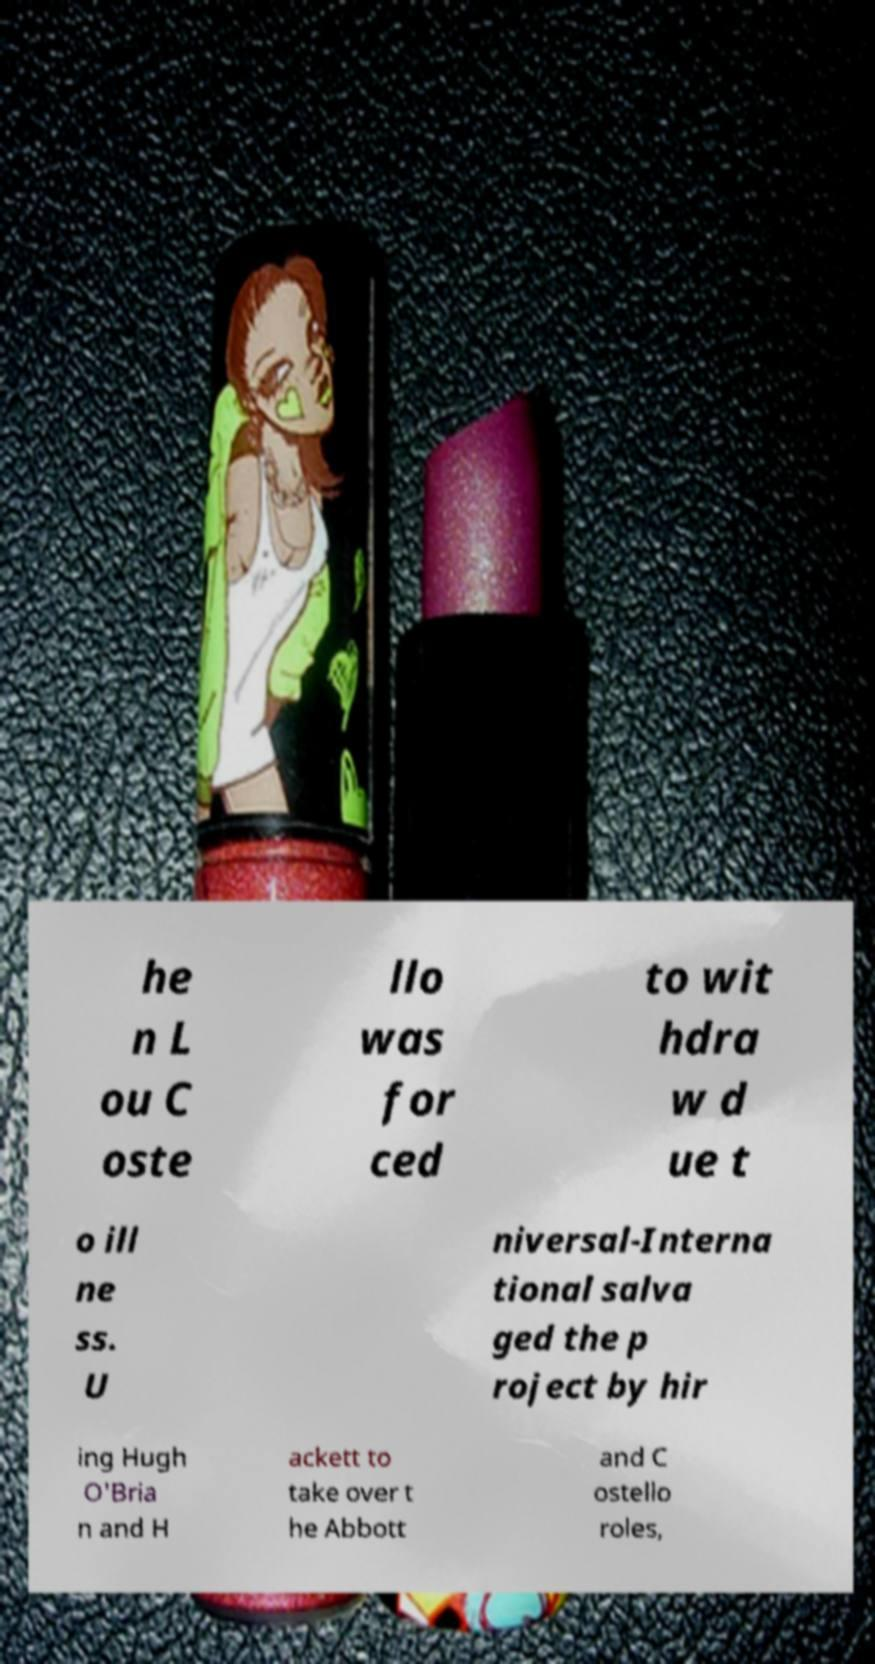What messages or text are displayed in this image? I need them in a readable, typed format. he n L ou C oste llo was for ced to wit hdra w d ue t o ill ne ss. U niversal-Interna tional salva ged the p roject by hir ing Hugh O'Bria n and H ackett to take over t he Abbott and C ostello roles, 